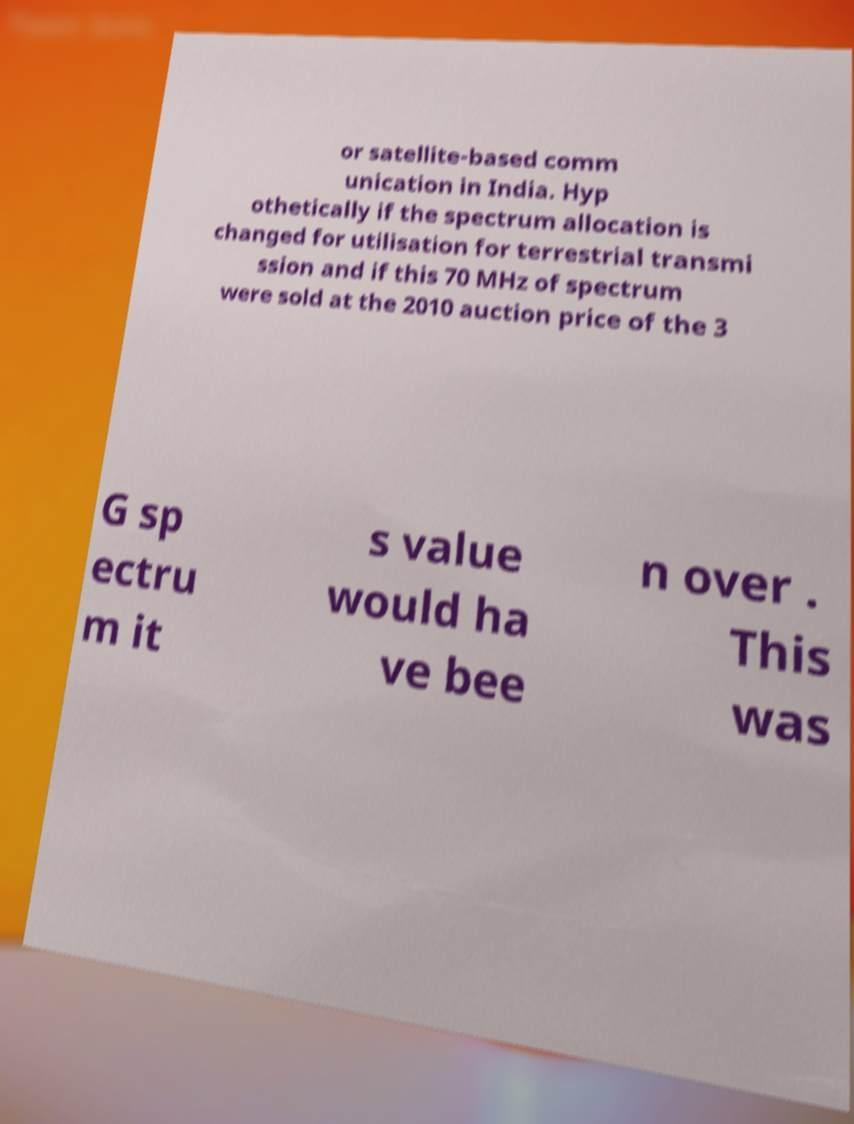For documentation purposes, I need the text within this image transcribed. Could you provide that? or satellite-based comm unication in India. Hyp othetically if the spectrum allocation is changed for utilisation for terrestrial transmi ssion and if this 70 MHz of spectrum were sold at the 2010 auction price of the 3 G sp ectru m it s value would ha ve bee n over . This was 